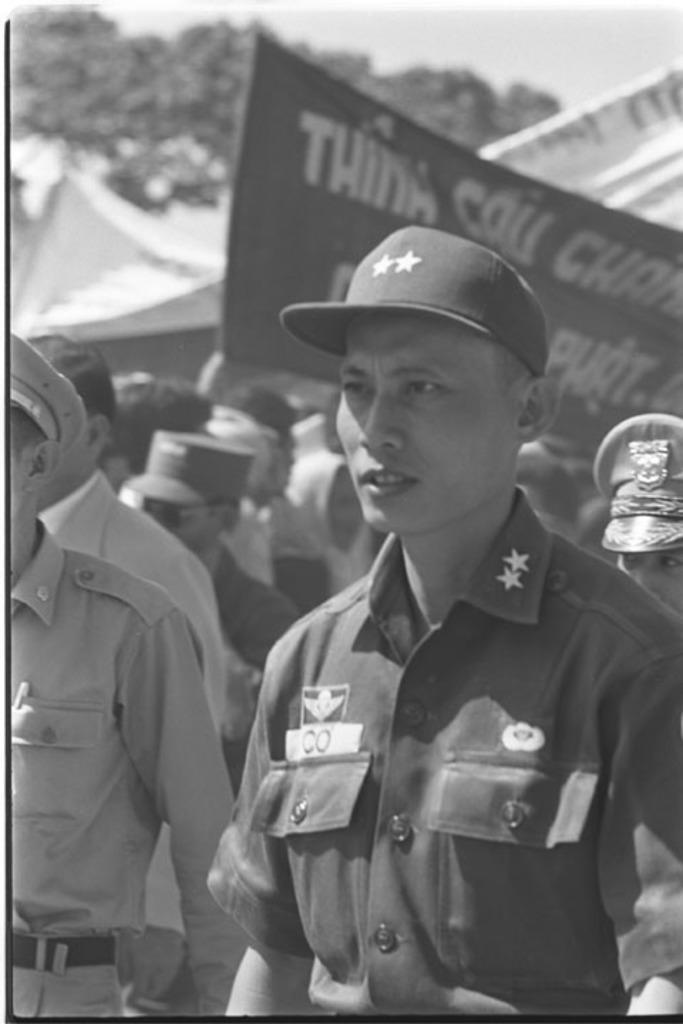In one or two sentences, can you explain what this image depicts? This image is a black and white image. This image is taken outdoors. In the background there is a tree and there are two banners with text on them. In the middle of the image there are a few people. 